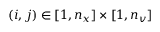Convert formula to latex. <formula><loc_0><loc_0><loc_500><loc_500>( i , j ) \in [ 1 , n _ { x } ] \times [ 1 , n _ { v } ]</formula> 